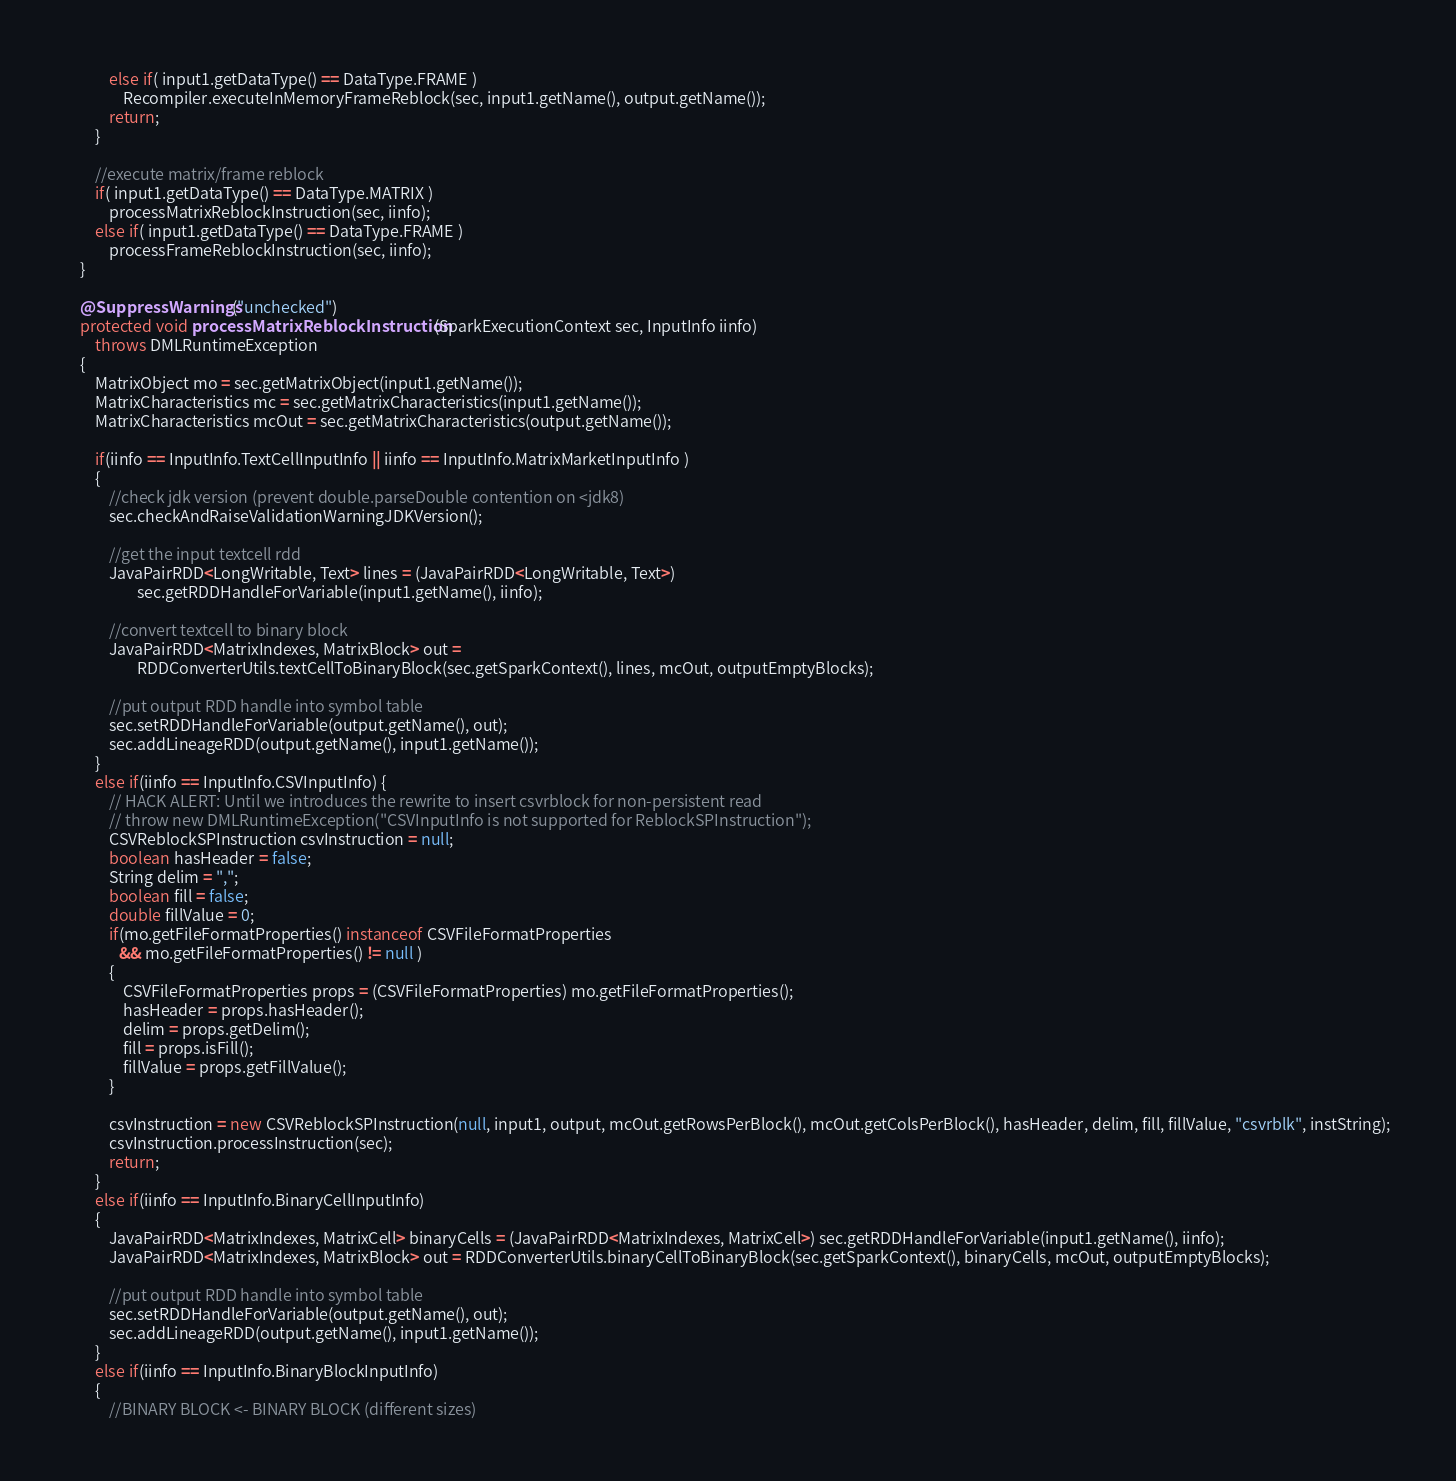<code> <loc_0><loc_0><loc_500><loc_500><_Java_>			else if( input1.getDataType() == DataType.FRAME )
				Recompiler.executeInMemoryFrameReblock(sec, input1.getName(), output.getName());	
			return;
		}
		
		//execute matrix/frame reblock
		if( input1.getDataType() == DataType.MATRIX )
			processMatrixReblockInstruction(sec, iinfo);
		else if( input1.getDataType() == DataType.FRAME )
			processFrameReblockInstruction(sec, iinfo);
	}

	@SuppressWarnings("unchecked")
	protected void processMatrixReblockInstruction(SparkExecutionContext sec, InputInfo iinfo) 
		throws DMLRuntimeException
	{
		MatrixObject mo = sec.getMatrixObject(input1.getName());
		MatrixCharacteristics mc = sec.getMatrixCharacteristics(input1.getName());
		MatrixCharacteristics mcOut = sec.getMatrixCharacteristics(output.getName());
		
		if(iinfo == InputInfo.TextCellInputInfo || iinfo == InputInfo.MatrixMarketInputInfo ) 
		{
			//check jdk version (prevent double.parseDouble contention on <jdk8)
			sec.checkAndRaiseValidationWarningJDKVersion();
			
			//get the input textcell rdd
			JavaPairRDD<LongWritable, Text> lines = (JavaPairRDD<LongWritable, Text>) 
					sec.getRDDHandleForVariable(input1.getName(), iinfo);
			
			//convert textcell to binary block
			JavaPairRDD<MatrixIndexes, MatrixBlock> out = 
					RDDConverterUtils.textCellToBinaryBlock(sec.getSparkContext(), lines, mcOut, outputEmptyBlocks);
			
			//put output RDD handle into symbol table
			sec.setRDDHandleForVariable(output.getName(), out);
			sec.addLineageRDD(output.getName(), input1.getName());
		}
		else if(iinfo == InputInfo.CSVInputInfo) {
			// HACK ALERT: Until we introduces the rewrite to insert csvrblock for non-persistent read
			// throw new DMLRuntimeException("CSVInputInfo is not supported for ReblockSPInstruction");
			CSVReblockSPInstruction csvInstruction = null;
			boolean hasHeader = false;
			String delim = ",";
			boolean fill = false;
			double fillValue = 0;
			if(mo.getFileFormatProperties() instanceof CSVFileFormatProperties 
			   && mo.getFileFormatProperties() != null ) 
			{
				CSVFileFormatProperties props = (CSVFileFormatProperties) mo.getFileFormatProperties();
				hasHeader = props.hasHeader();
				delim = props.getDelim();
				fill = props.isFill();
				fillValue = props.getFillValue();
			}
			
			csvInstruction = new CSVReblockSPInstruction(null, input1, output, mcOut.getRowsPerBlock(), mcOut.getColsPerBlock(), hasHeader, delim, fill, fillValue, "csvrblk", instString);
			csvInstruction.processInstruction(sec);
			return;
		}
		else if(iinfo == InputInfo.BinaryCellInputInfo) 
		{
			JavaPairRDD<MatrixIndexes, MatrixCell> binaryCells = (JavaPairRDD<MatrixIndexes, MatrixCell>) sec.getRDDHandleForVariable(input1.getName(), iinfo);
			JavaPairRDD<MatrixIndexes, MatrixBlock> out = RDDConverterUtils.binaryCellToBinaryBlock(sec.getSparkContext(), binaryCells, mcOut, outputEmptyBlocks);
			
			//put output RDD handle into symbol table
			sec.setRDDHandleForVariable(output.getName(), out);
			sec.addLineageRDD(output.getName(), input1.getName());
		}
		else if(iinfo == InputInfo.BinaryBlockInputInfo) 
		{
			//BINARY BLOCK <- BINARY BLOCK (different sizes)</code> 